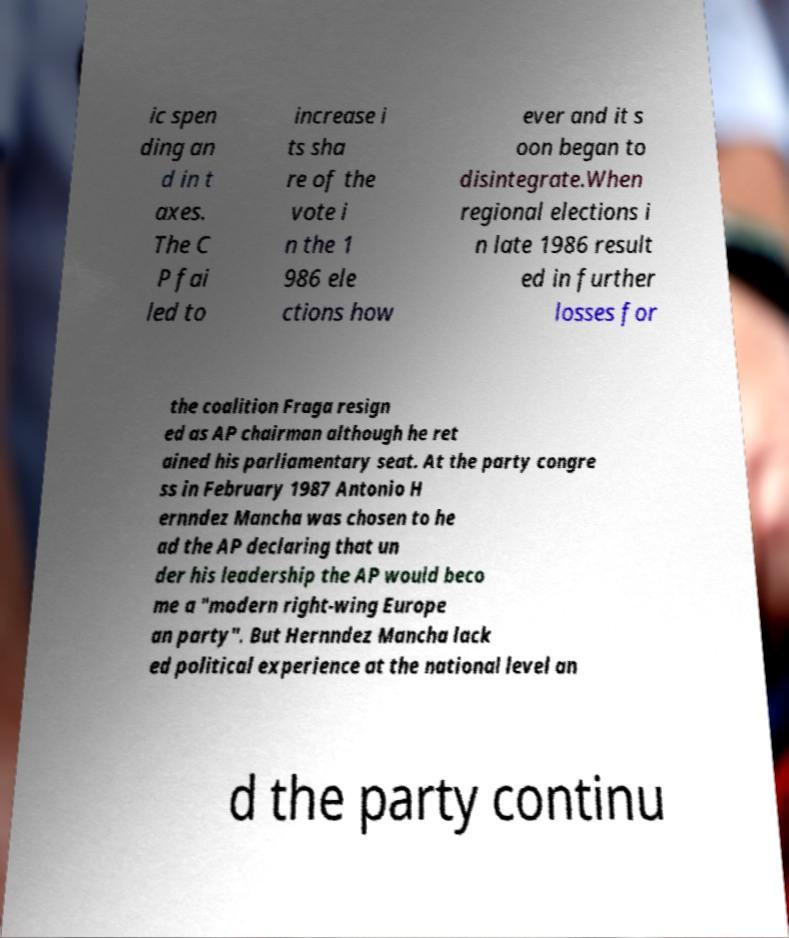Could you assist in decoding the text presented in this image and type it out clearly? ic spen ding an d in t axes. The C P fai led to increase i ts sha re of the vote i n the 1 986 ele ctions how ever and it s oon began to disintegrate.When regional elections i n late 1986 result ed in further losses for the coalition Fraga resign ed as AP chairman although he ret ained his parliamentary seat. At the party congre ss in February 1987 Antonio H ernndez Mancha was chosen to he ad the AP declaring that un der his leadership the AP would beco me a "modern right-wing Europe an party". But Hernndez Mancha lack ed political experience at the national level an d the party continu 